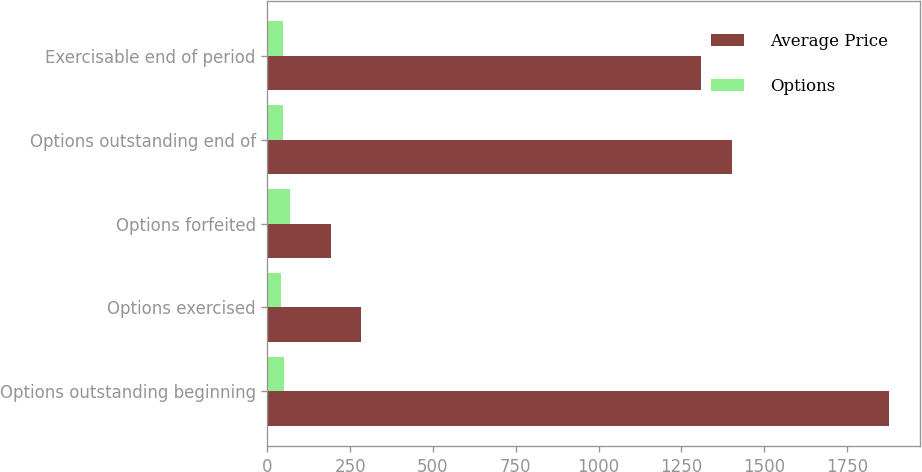Convert chart. <chart><loc_0><loc_0><loc_500><loc_500><stacked_bar_chart><ecel><fcel>Options outstanding beginning<fcel>Options exercised<fcel>Options forfeited<fcel>Options outstanding end of<fcel>Exercisable end of period<nl><fcel>Average Price<fcel>1878<fcel>282<fcel>192<fcel>1404<fcel>1309<nl><fcel>Options<fcel>49<fcel>40<fcel>68<fcel>48<fcel>47<nl></chart> 